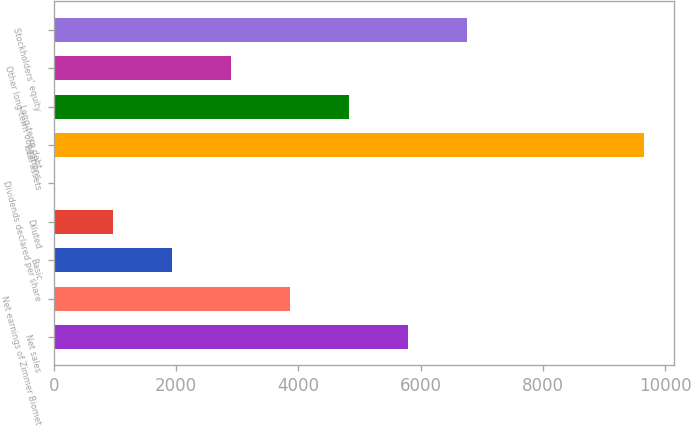Convert chart to OTSL. <chart><loc_0><loc_0><loc_500><loc_500><bar_chart><fcel>Net sales<fcel>Net earnings of Zimmer Biomet<fcel>Basic<fcel>Diluted<fcel>Dividends declared per share<fcel>Total assets<fcel>Long-term debt<fcel>Other long-term obligations<fcel>Stockholders' equity<nl><fcel>5795.14<fcel>3863.72<fcel>1932.3<fcel>966.59<fcel>0.88<fcel>9658<fcel>4829.43<fcel>2898.01<fcel>6760.85<nl></chart> 